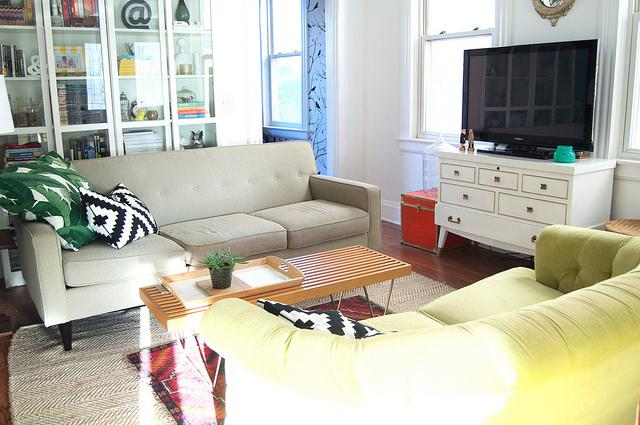What color is the vase on the right side of the white entertainment center?

Choices:
A) turquoise
B) yellow
C) red
D) red turquoise 